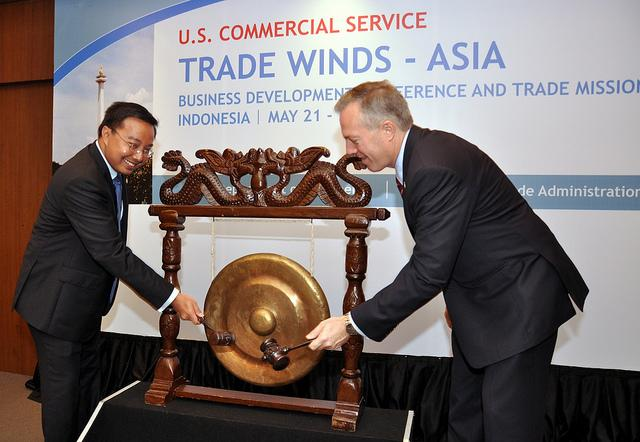What does hitting the gong here signal? instrument 